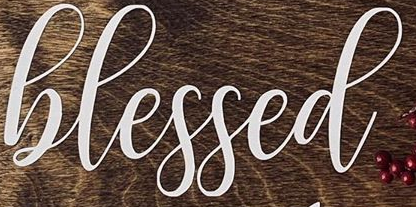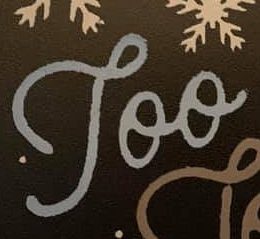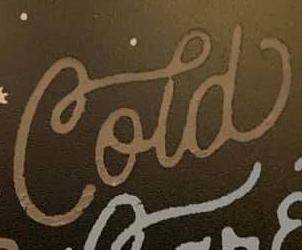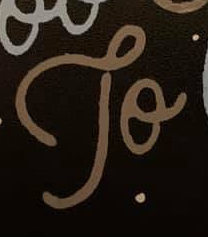What text is displayed in these images sequentially, separated by a semicolon? hlessed; Too; Cold; To 